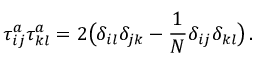<formula> <loc_0><loc_0><loc_500><loc_500>\tau _ { i j } ^ { a } \tau _ { k l } ^ { a } = 2 \left ( \delta _ { i l } \delta _ { j k } - \frac { 1 } { N } \delta _ { i j } \delta _ { k l } \right ) \, .</formula> 